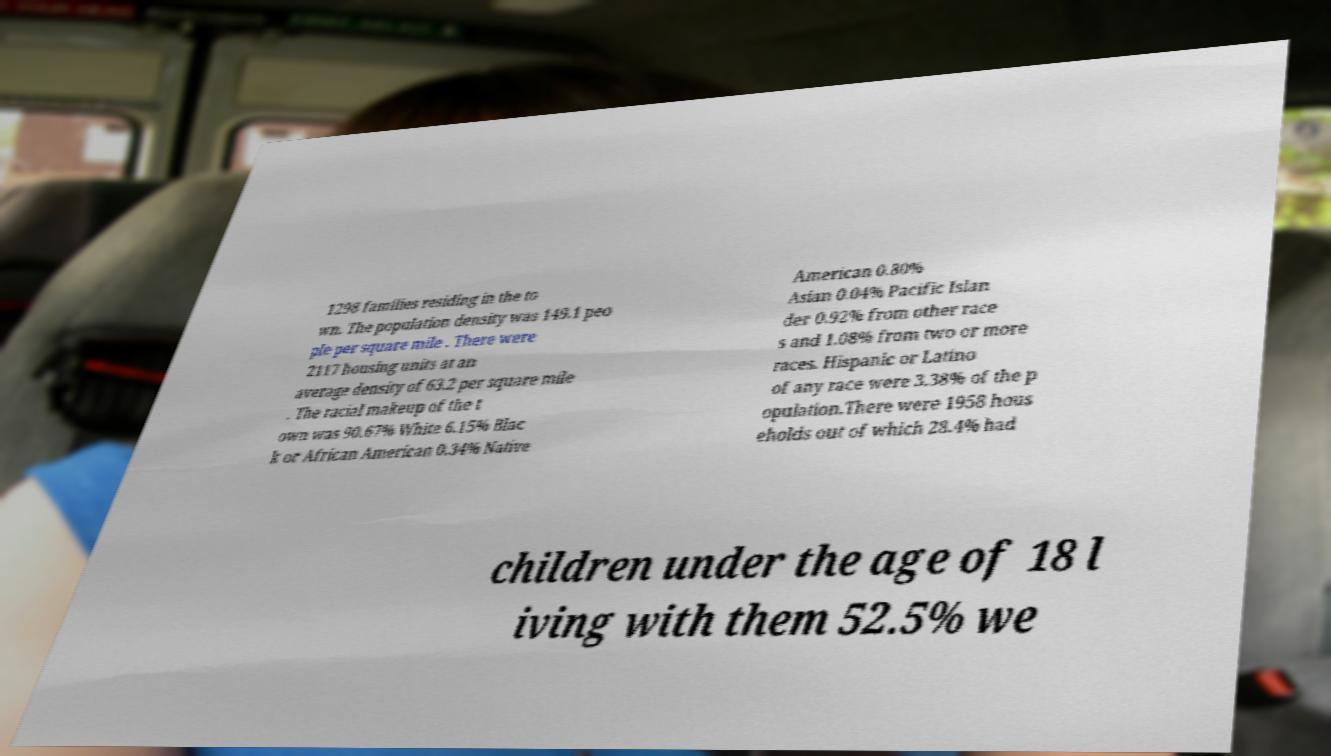There's text embedded in this image that I need extracted. Can you transcribe it verbatim? 1298 families residing in the to wn. The population density was 149.1 peo ple per square mile . There were 2117 housing units at an average density of 63.2 per square mile . The racial makeup of the t own was 90.67% White 6.15% Blac k or African American 0.34% Native American 0.80% Asian 0.04% Pacific Islan der 0.92% from other race s and 1.08% from two or more races. Hispanic or Latino of any race were 3.38% of the p opulation.There were 1958 hous eholds out of which 28.4% had children under the age of 18 l iving with them 52.5% we 